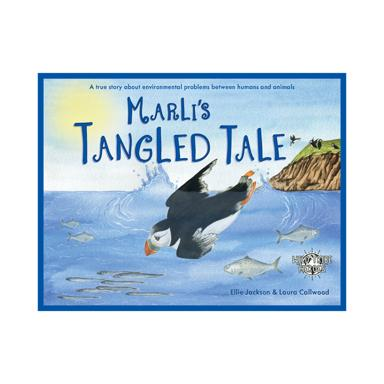What is the title of the children's book mentioned in the image? The title of the children's book is "Marli's Tangled Tale" by Ellie Jackson and Loura Collwood. Who are the authors of the book? The authors of the book are Ellie Jackson and Loura Collwood. 